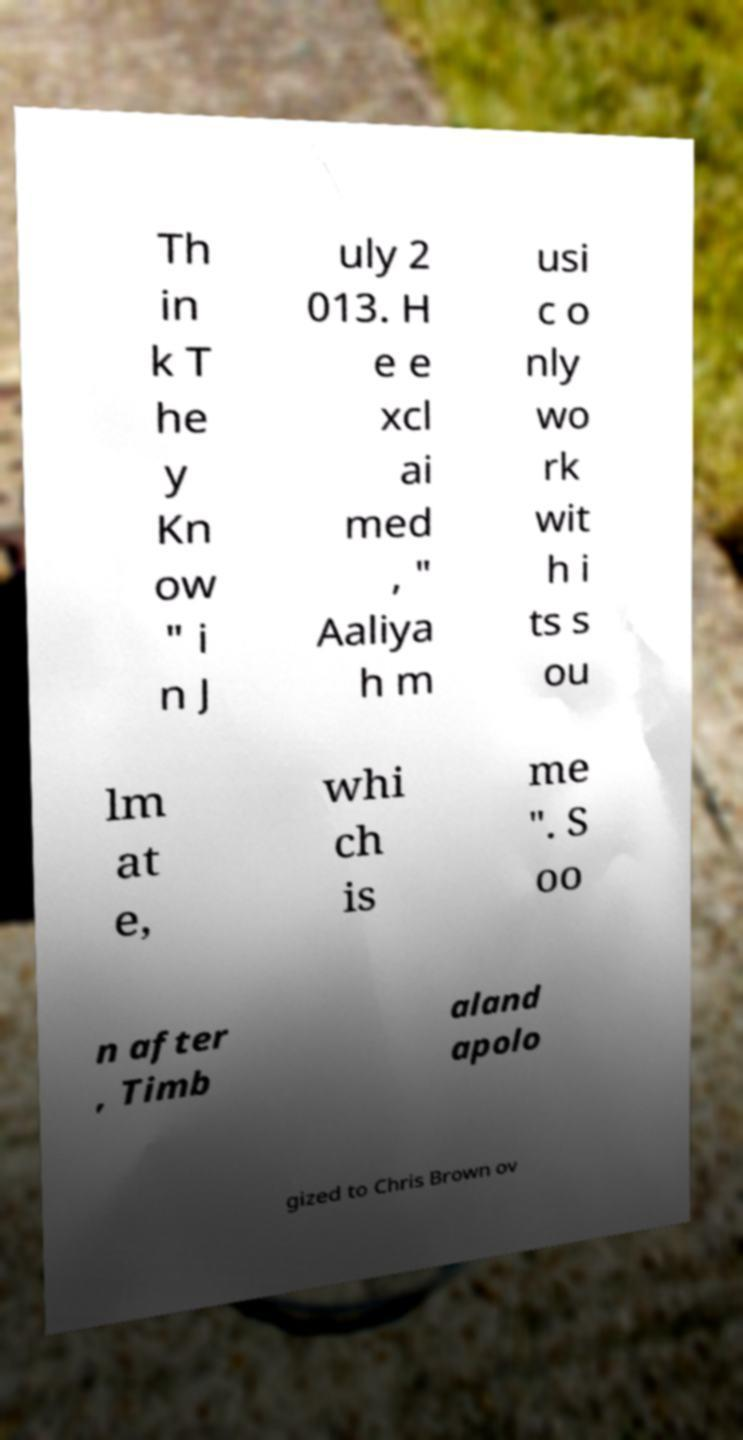What messages or text are displayed in this image? I need them in a readable, typed format. Th in k T he y Kn ow " i n J uly 2 013. H e e xcl ai med , " Aaliya h m usi c o nly wo rk wit h i ts s ou lm at e, whi ch is me ". S oo n after , Timb aland apolo gized to Chris Brown ov 